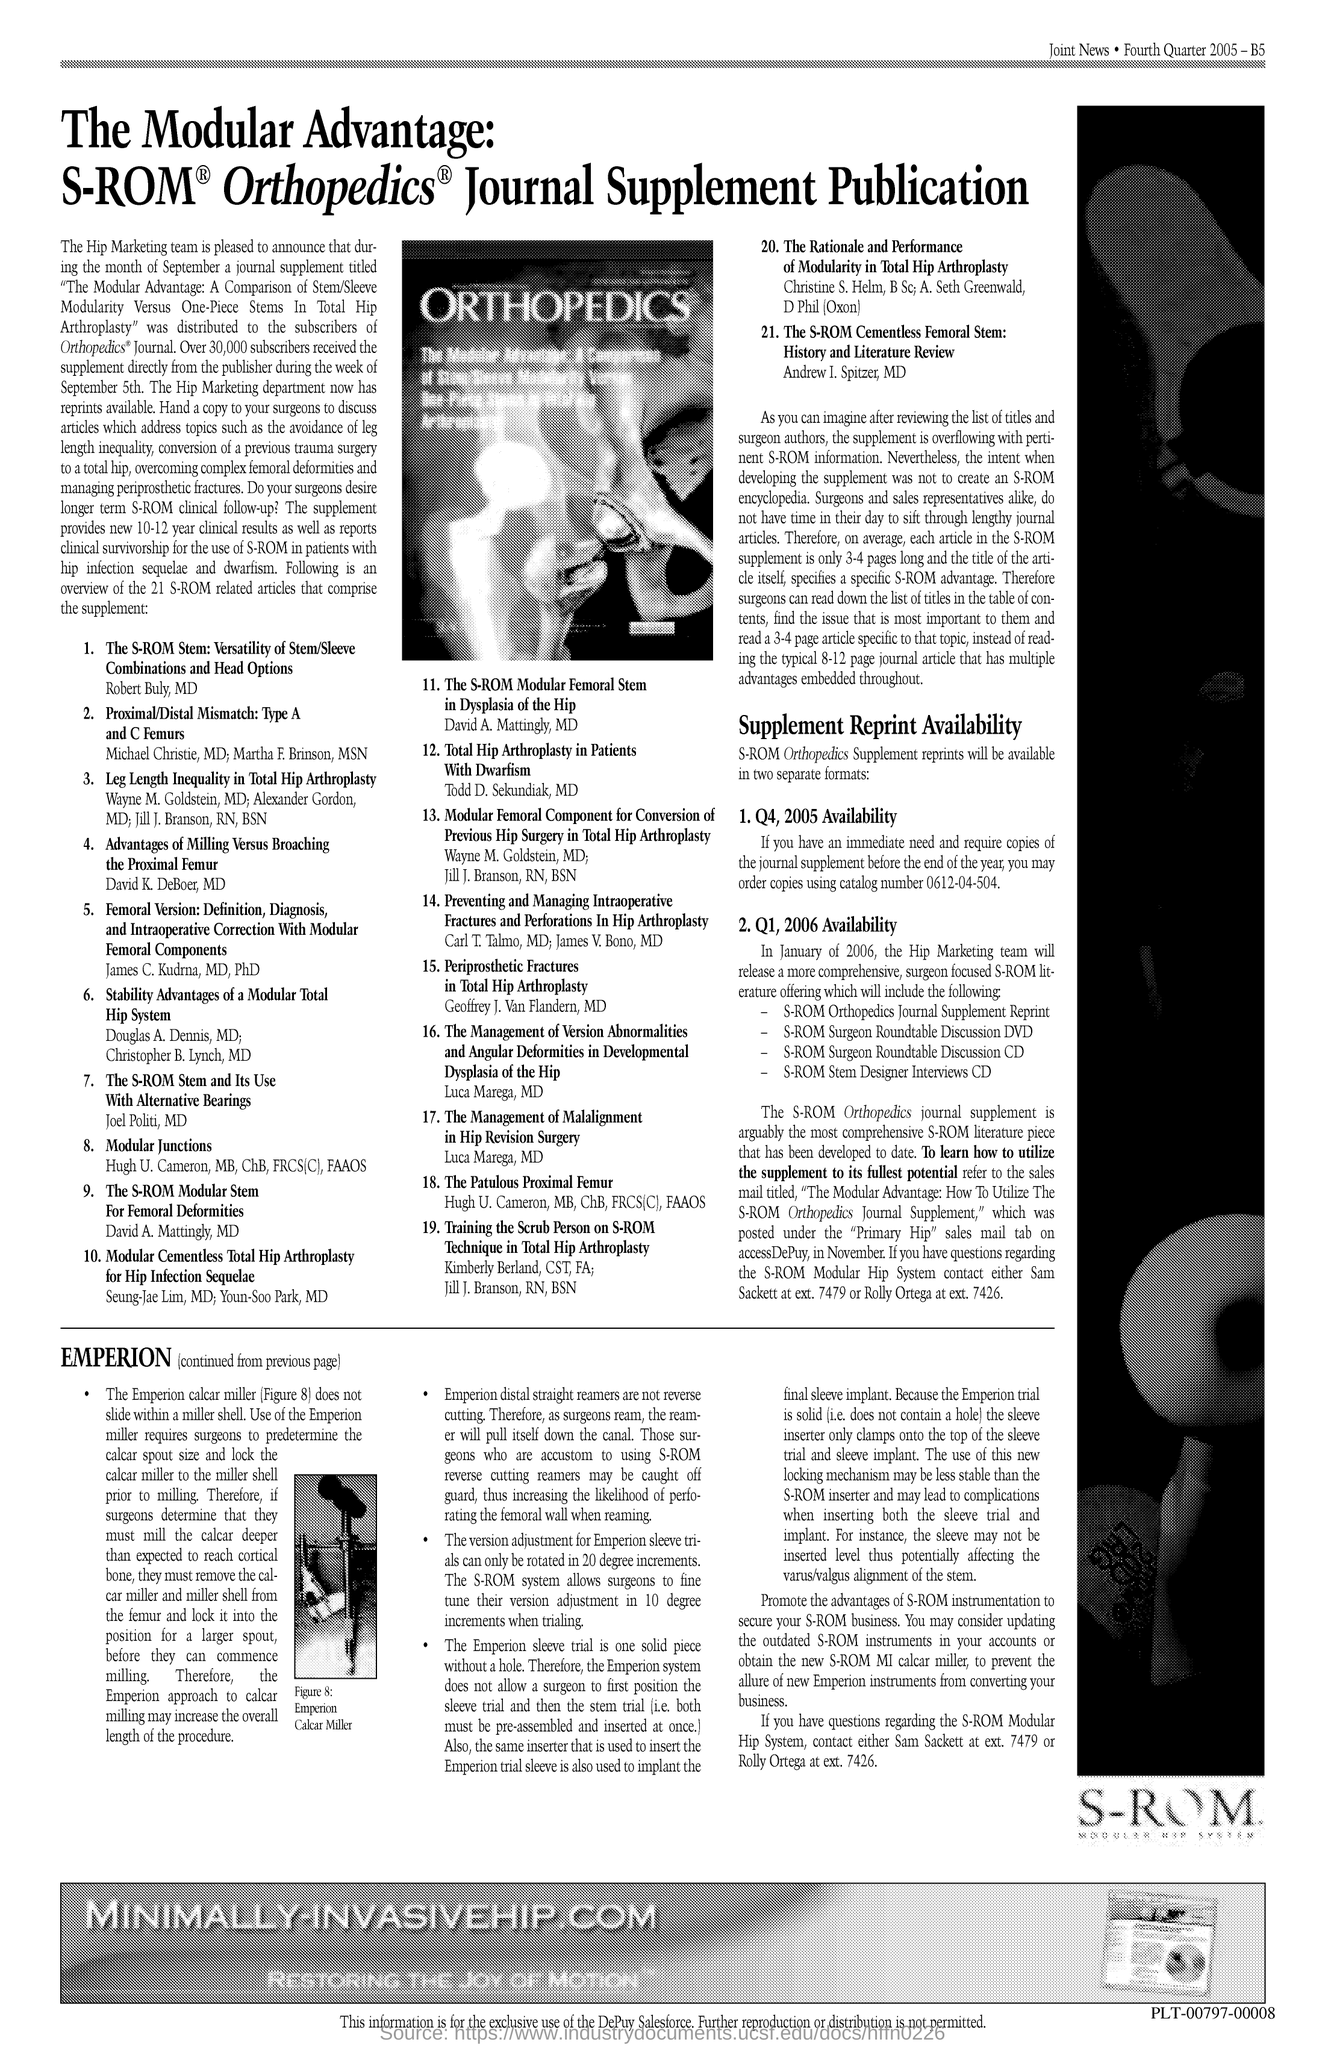What is the title that is written in the image?
Your answer should be very brief. Orthopedics. 